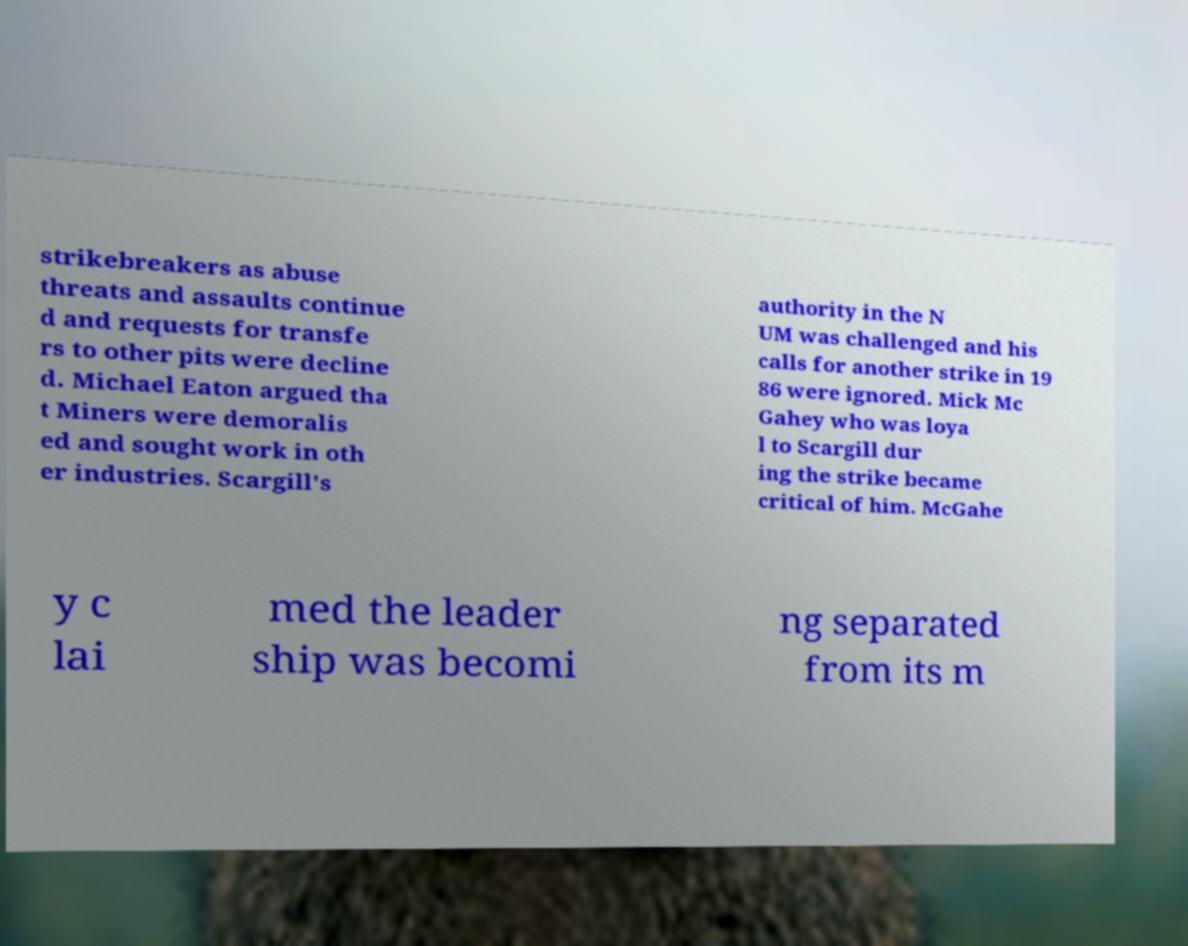Please read and relay the text visible in this image. What does it say? strikebreakers as abuse threats and assaults continue d and requests for transfe rs to other pits were decline d. Michael Eaton argued tha t Miners were demoralis ed and sought work in oth er industries. Scargill's authority in the N UM was challenged and his calls for another strike in 19 86 were ignored. Mick Mc Gahey who was loya l to Scargill dur ing the strike became critical of him. McGahe y c lai med the leader ship was becomi ng separated from its m 